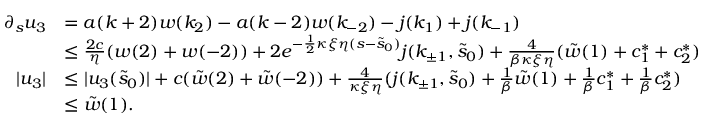<formula> <loc_0><loc_0><loc_500><loc_500>\begin{array} { r l } { \partial _ { s } u _ { 3 } } & { = a ( k + 2 ) w ( k _ { 2 } ) - a ( k - 2 ) w ( k _ { - 2 } ) - j ( k _ { 1 } ) + j ( k _ { - 1 } ) } \\ & { \leq \frac { 2 c } \eta ( w ( 2 ) + w ( - 2 ) ) + 2 e ^ { - \frac { 1 } { 2 } \kappa \xi \eta ( s - \tilde { s } _ { 0 } ) } j ( k _ { \pm 1 } , \tilde { s } _ { 0 } ) + \frac { 4 } \beta \kappa \xi \eta } ( \tilde { w } ( 1 ) + c _ { 1 } ^ { \ast } + c _ { 2 } ^ { \ast } ) } \\ { | u _ { 3 } | } & { \leq | u _ { 3 } ( \tilde { s } _ { 0 } ) | + c ( \tilde { w } ( 2 ) + \tilde { w } ( - 2 ) ) + \frac { 4 } \kappa \xi \eta } ( j ( k _ { \pm 1 } , \tilde { s } _ { 0 } ) + \frac { 1 } { \beta } \tilde { w } ( 1 ) + \frac { 1 } { \beta } c _ { 1 } ^ { \ast } + \frac { 1 } \beta } c _ { 2 } ^ { \ast } ) } \\ & { \leq \tilde { w } ( 1 ) . } \end{array}</formula> 